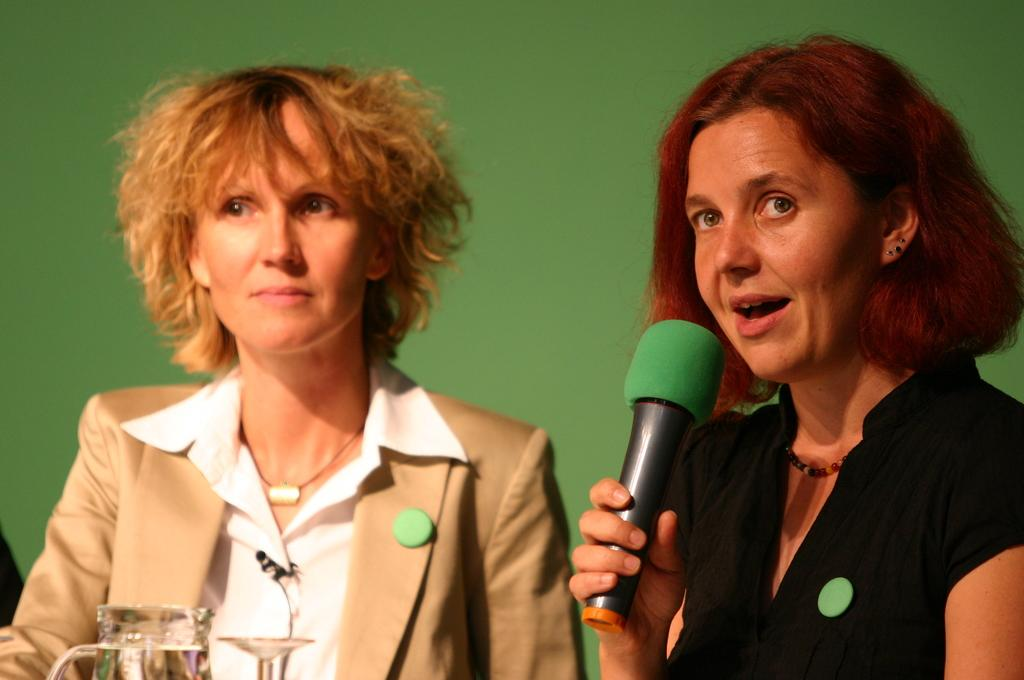How many people are present in the image? There are two persons sitting in the image. What is one person doing with their hands? One person is holding a microphone. What are two objects visible in the image? There is a jar and a glass in the image. What can be seen in the background of the image? There is a wall in the background of the image. What type of art is being discussed by the persons in the image? There is no indication in the image that the persons are discussing any type of art. How many songs are being sung by the person holding the microphone? The image does not show the person singing any songs, so it cannot be determined from the picture. 